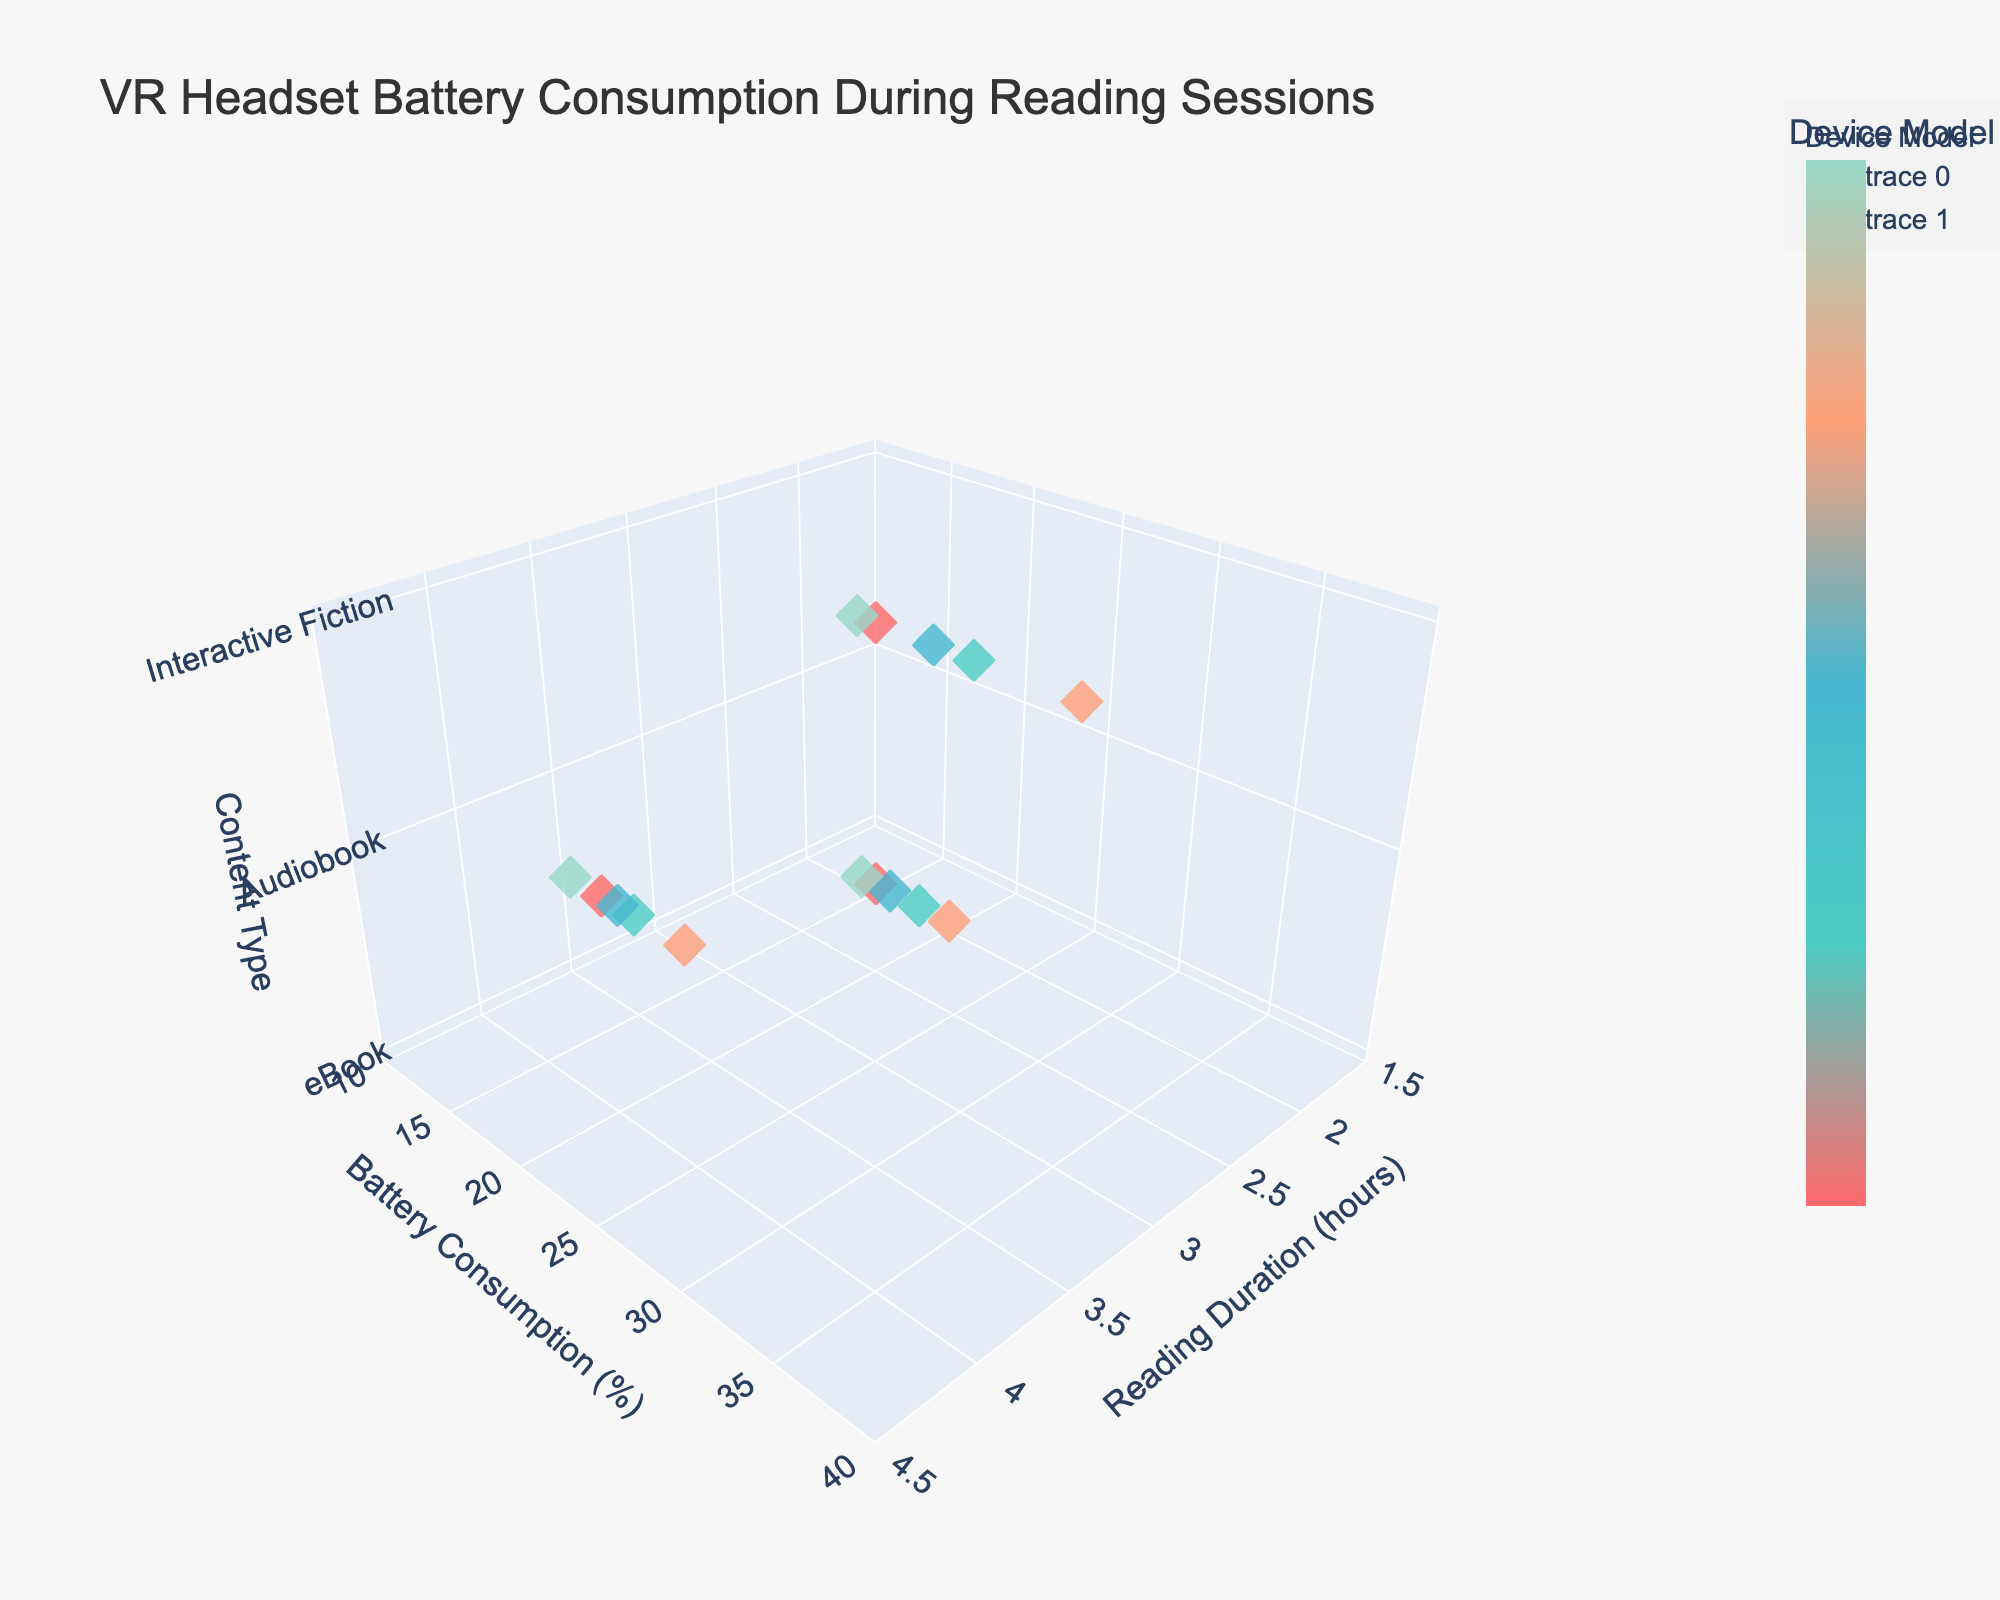What's the title of the plot? The title of the plot is displayed at the top of the figure.
Answer: VR Headset Battery Consumption During Reading Sessions How many different device models are represented in the plot? You can tell by the different unique colors used and the colorbar legend provided.
Answer: 5 Which content type shows the highest battery consumption rate? By observing the y-axis values for each content type (z-axis), the Interactive Fiction content type generally shows the highest battery consumption rates.
Answer: Interactive Fiction What is the battery consumption rate for Oculus Quest 2 while reading an eBook for 2 hours? Find the point corresponding to Oculus Quest 2, eBook, and 2 hours reading duration and read its y-value.
Answer: 15% Between Valve Index and Pico Neo 3, which device model uses more battery on average for Interactive Fiction? Compare the battery consumption rates of both devices for Interactive Fiction content. The Valve Index values are higher than Pico Neo 3.
Answer: Valve Index For which device model does Audiobook reading for 4 hours consume the least battery? Compare y-values for Audiobook content at 4 hours for all devices. Pico Neo 3 has the lowest value.
Answer: Pico Neo 3 What is the approximate reading duration for an HTC Vive Pro 2 user reading an eBook if their battery consumption is about 18%? Find the data point where HTC Vive Pro 2 reads an eBook, and the battery consumption is 18%.
Answer: 2 hours Which device model exhibits the most uniform battery consumption across all content types? Review the spread of battery consumption rates for each device model across all content types. Pico Neo 3 has the smallest variation.
Answer: Pico Neo 3 Do any device models have a battery consumption rate for eBooks that is exactly the same despite different reading durations? Examine the eBook battery consumption rates for all devices and their respective reading durations. No device shows the same rate for different durations.
Answer: No 